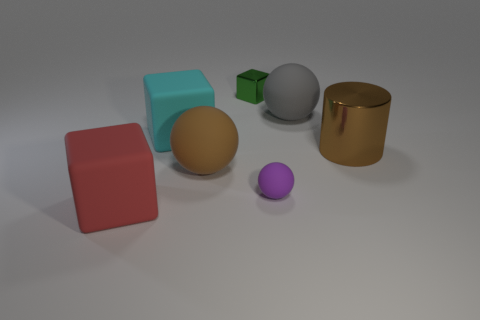What is the size of the matte sphere that is the same color as the big metal thing?
Offer a terse response. Large. What is the shape of the big cyan rubber object?
Provide a short and direct response. Cube. What number of cylinders have the same material as the small block?
Your answer should be very brief. 1. Is the color of the big metal object the same as the big matte sphere that is left of the large gray matte thing?
Give a very brief answer. Yes. What number of yellow matte cubes are there?
Your answer should be very brief. 0. Is there a large sphere of the same color as the big shiny cylinder?
Your response must be concise. Yes. The metallic thing that is behind the matte cube behind the tiny object that is on the right side of the green cube is what color?
Provide a succinct answer. Green. Does the tiny purple sphere have the same material as the large brown object that is on the right side of the gray rubber sphere?
Offer a very short reply. No. What is the material of the large cyan object?
Your answer should be compact. Rubber. What number of other things are there of the same material as the red cube
Provide a short and direct response. 4. 